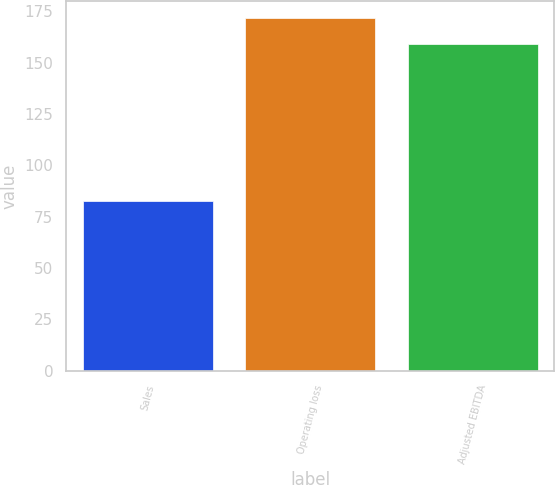<chart> <loc_0><loc_0><loc_500><loc_500><bar_chart><fcel>Sales<fcel>Operating loss<fcel>Adjusted EBITDA<nl><fcel>82.6<fcel>171.5<fcel>159.3<nl></chart> 